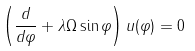<formula> <loc_0><loc_0><loc_500><loc_500>\left ( \frac { d } { d \varphi } + \lambda \Omega \sin \varphi \right ) u ( \varphi ) = 0</formula> 